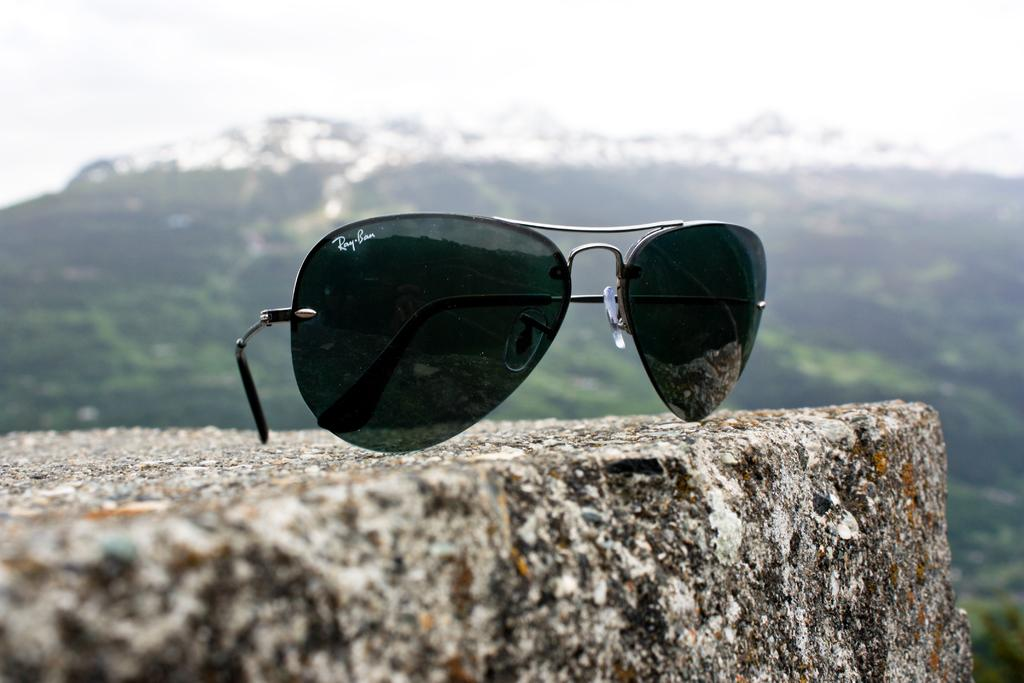What type of sunglasses are in the image? There are Ray Ban sunglasses in the image. Where are the sunglasses located? The sunglasses are on a rock. What can be seen in the background of the image? There is a hill and the sky visible in the background of the image. How much money does the pet have in the image? There is no pet or money present in the image. What is the pet's fear in the image? There is no pet or fear present in the image. 